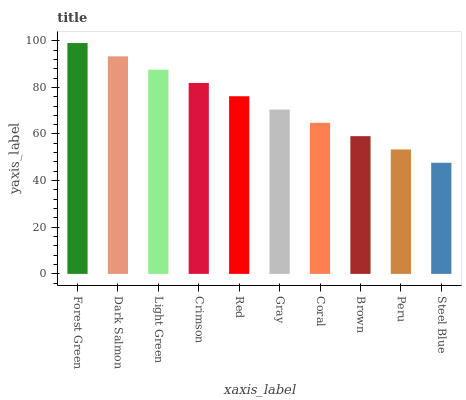Is Dark Salmon the minimum?
Answer yes or no. No. Is Dark Salmon the maximum?
Answer yes or no. No. Is Forest Green greater than Dark Salmon?
Answer yes or no. Yes. Is Dark Salmon less than Forest Green?
Answer yes or no. Yes. Is Dark Salmon greater than Forest Green?
Answer yes or no. No. Is Forest Green less than Dark Salmon?
Answer yes or no. No. Is Red the high median?
Answer yes or no. Yes. Is Gray the low median?
Answer yes or no. Yes. Is Light Green the high median?
Answer yes or no. No. Is Dark Salmon the low median?
Answer yes or no. No. 